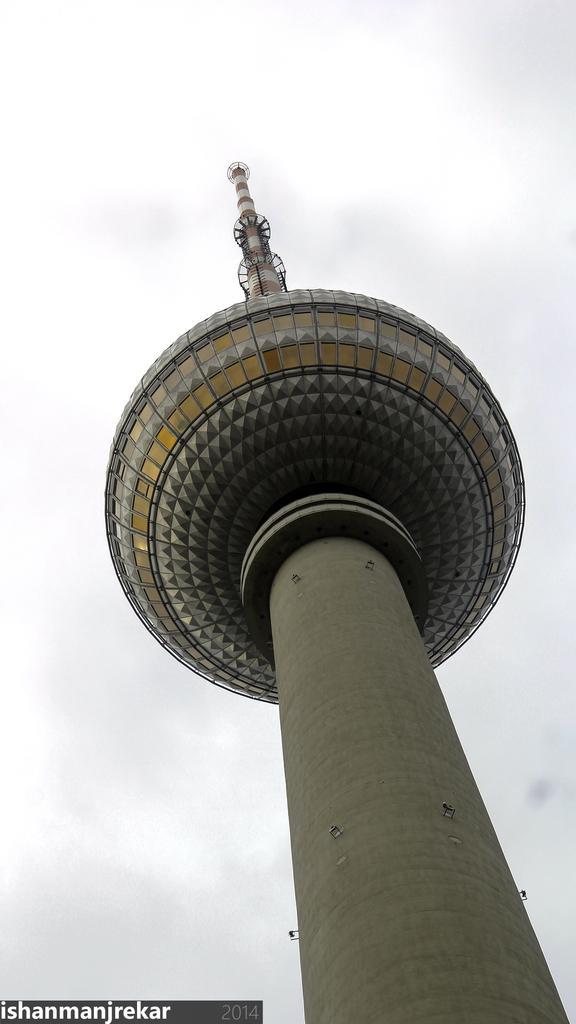In one or two sentences, can you explain what this image depicts? In this image there is a tower. The sky is cloudy. At the bottom few texts are there. 